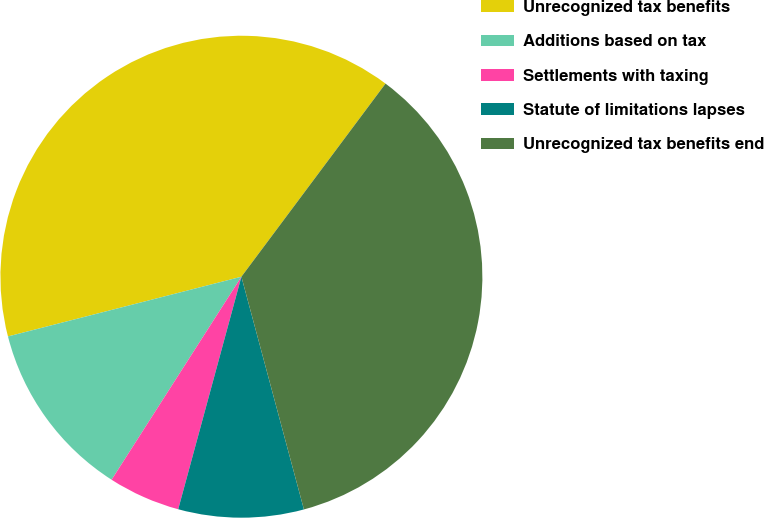Convert chart to OTSL. <chart><loc_0><loc_0><loc_500><loc_500><pie_chart><fcel>Unrecognized tax benefits<fcel>Additions based on tax<fcel>Settlements with taxing<fcel>Statute of limitations lapses<fcel>Unrecognized tax benefits end<nl><fcel>39.19%<fcel>11.96%<fcel>4.83%<fcel>8.4%<fcel>35.62%<nl></chart> 